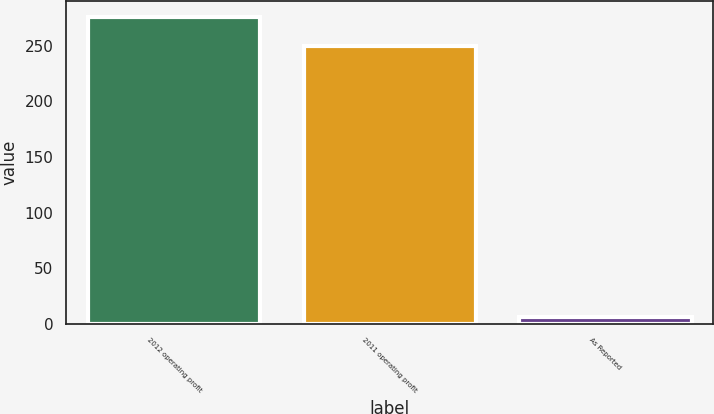<chart> <loc_0><loc_0><loc_500><loc_500><bar_chart><fcel>2012 operating profit<fcel>2011 operating profit<fcel>As Reported<nl><fcel>275.88<fcel>250<fcel>6.2<nl></chart> 